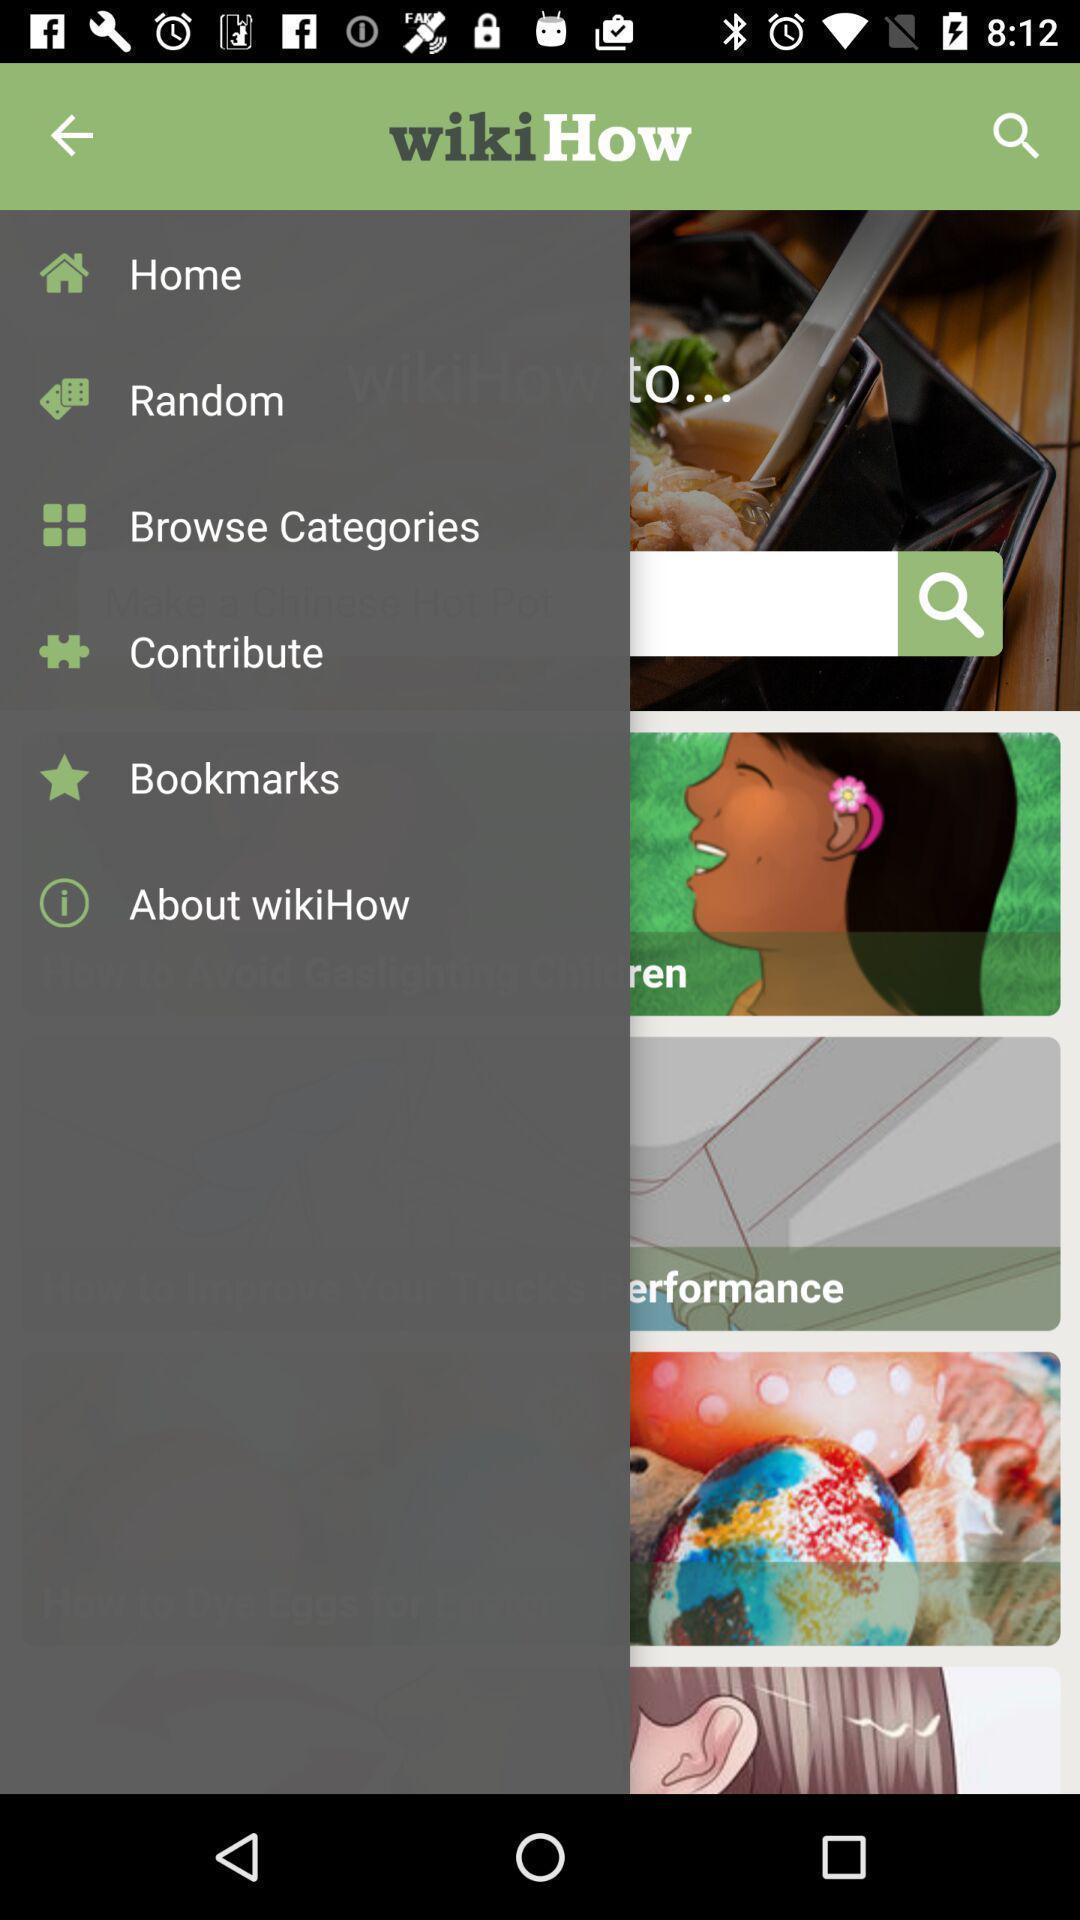What details can you identify in this image? Screen displaying the list of options. 